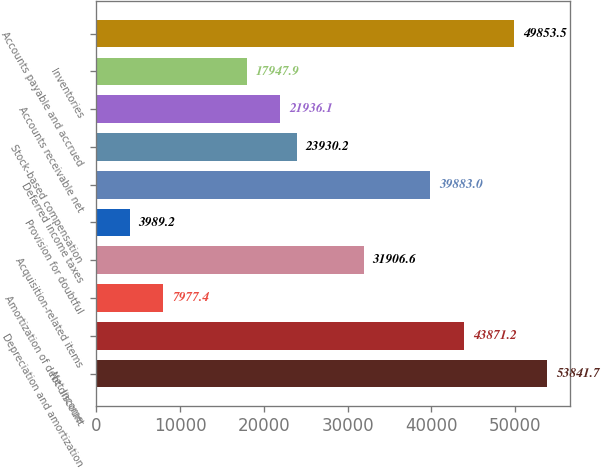Convert chart. <chart><loc_0><loc_0><loc_500><loc_500><bar_chart><fcel>Net income<fcel>Depreciation and amortization<fcel>Amortization of debt discount<fcel>Acquisition-related items<fcel>Provision for doubtful<fcel>Deferred income taxes<fcel>Stock-based compensation<fcel>Accounts receivable net<fcel>Inventories<fcel>Accounts payable and accrued<nl><fcel>53841.7<fcel>43871.2<fcel>7977.4<fcel>31906.6<fcel>3989.2<fcel>39883<fcel>23930.2<fcel>21936.1<fcel>17947.9<fcel>49853.5<nl></chart> 